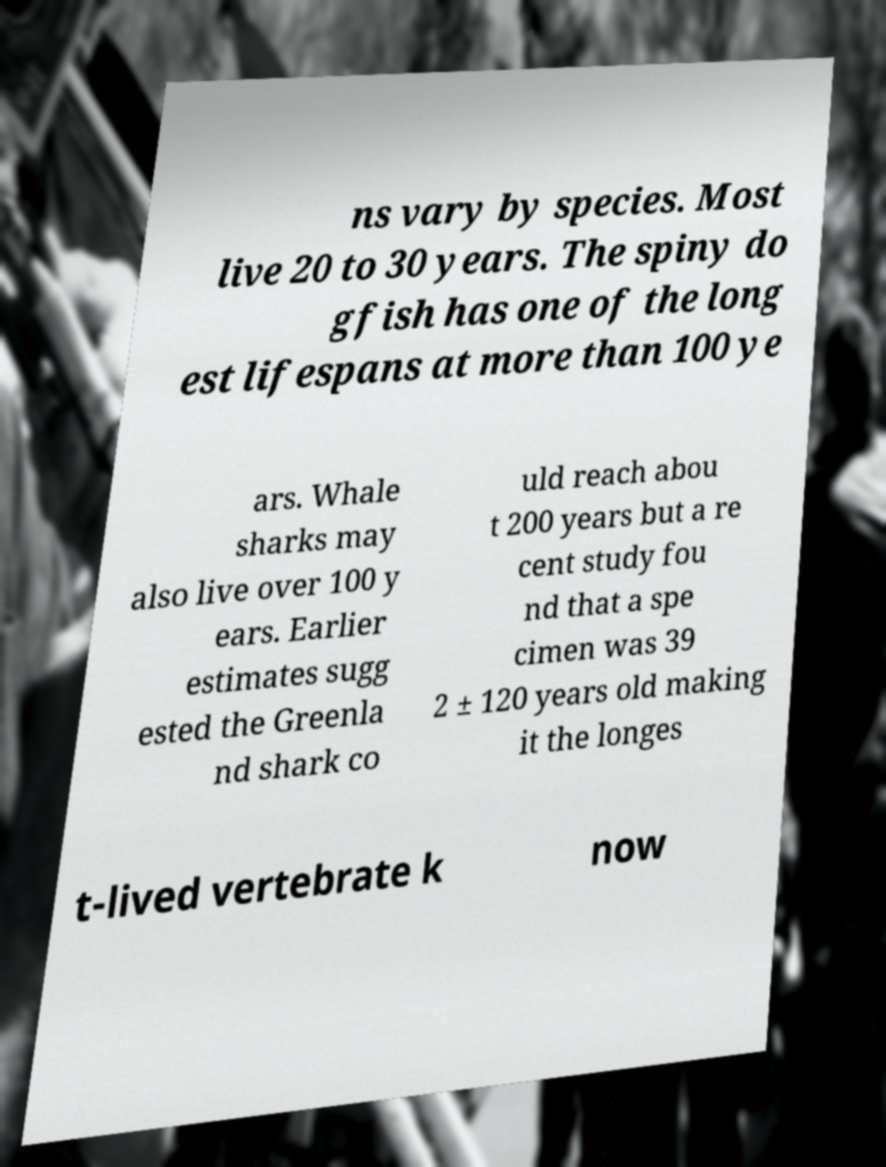Please identify and transcribe the text found in this image. ns vary by species. Most live 20 to 30 years. The spiny do gfish has one of the long est lifespans at more than 100 ye ars. Whale sharks may also live over 100 y ears. Earlier estimates sugg ested the Greenla nd shark co uld reach abou t 200 years but a re cent study fou nd that a spe cimen was 39 2 ± 120 years old making it the longes t-lived vertebrate k now 